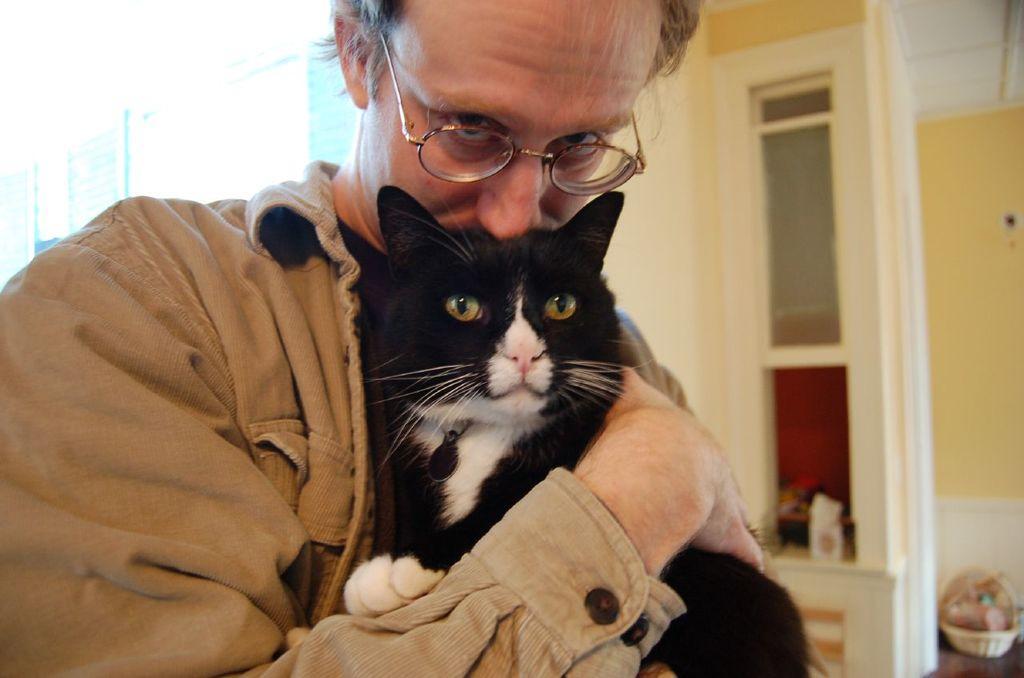Can you describe this image briefly? In the front of the image I can see a person is holding a cat. In the background of the image there are walls, cupboard, basket and things.   